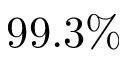<formula> <loc_0><loc_0><loc_500><loc_500>9 9 . 3 \%</formula> 